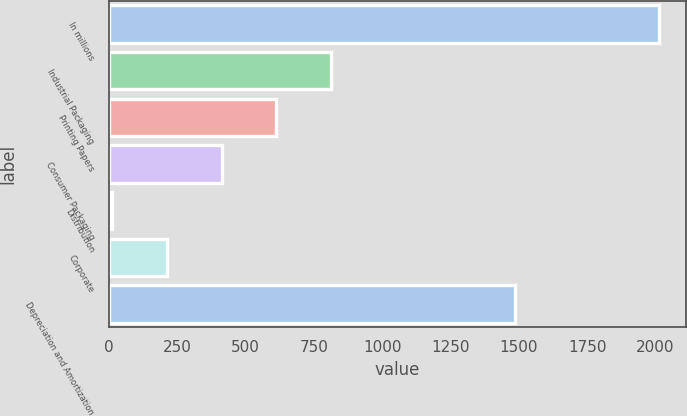Convert chart. <chart><loc_0><loc_0><loc_500><loc_500><bar_chart><fcel>In millions<fcel>Industrial Packaging<fcel>Printing Papers<fcel>Consumer Packaging<fcel>Distribution<fcel>Corporate<fcel>Depreciation and Amortization<nl><fcel>2012<fcel>812.6<fcel>612.7<fcel>412.8<fcel>13<fcel>212.9<fcel>1486<nl></chart> 